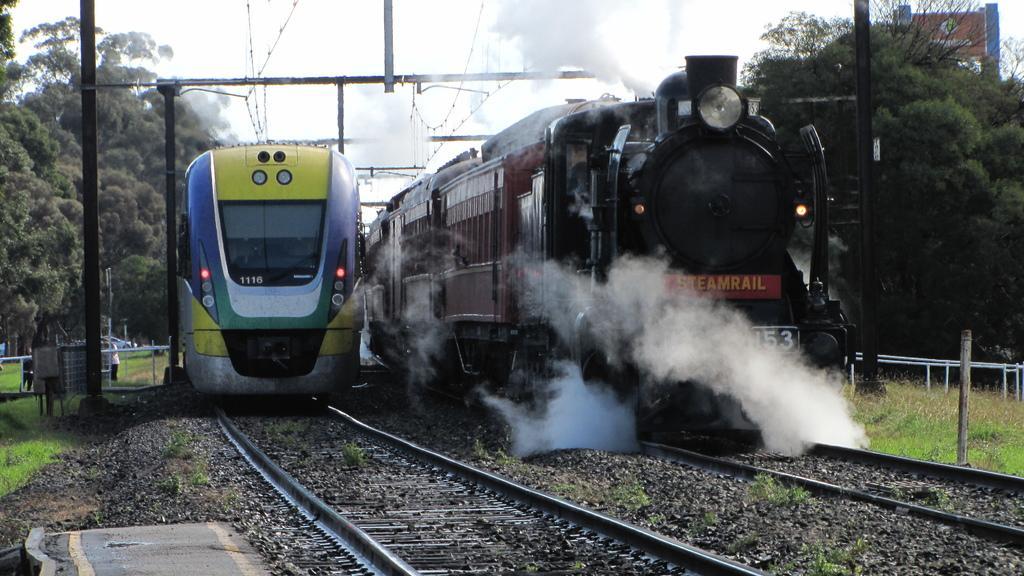Describe this image in one or two sentences. In this picture there are two trains moving on the two railway tracks. One train is in maroon color and the other train is in yellow and blue color. There are poles here. We can observe some trees. In the background there is a sky. 